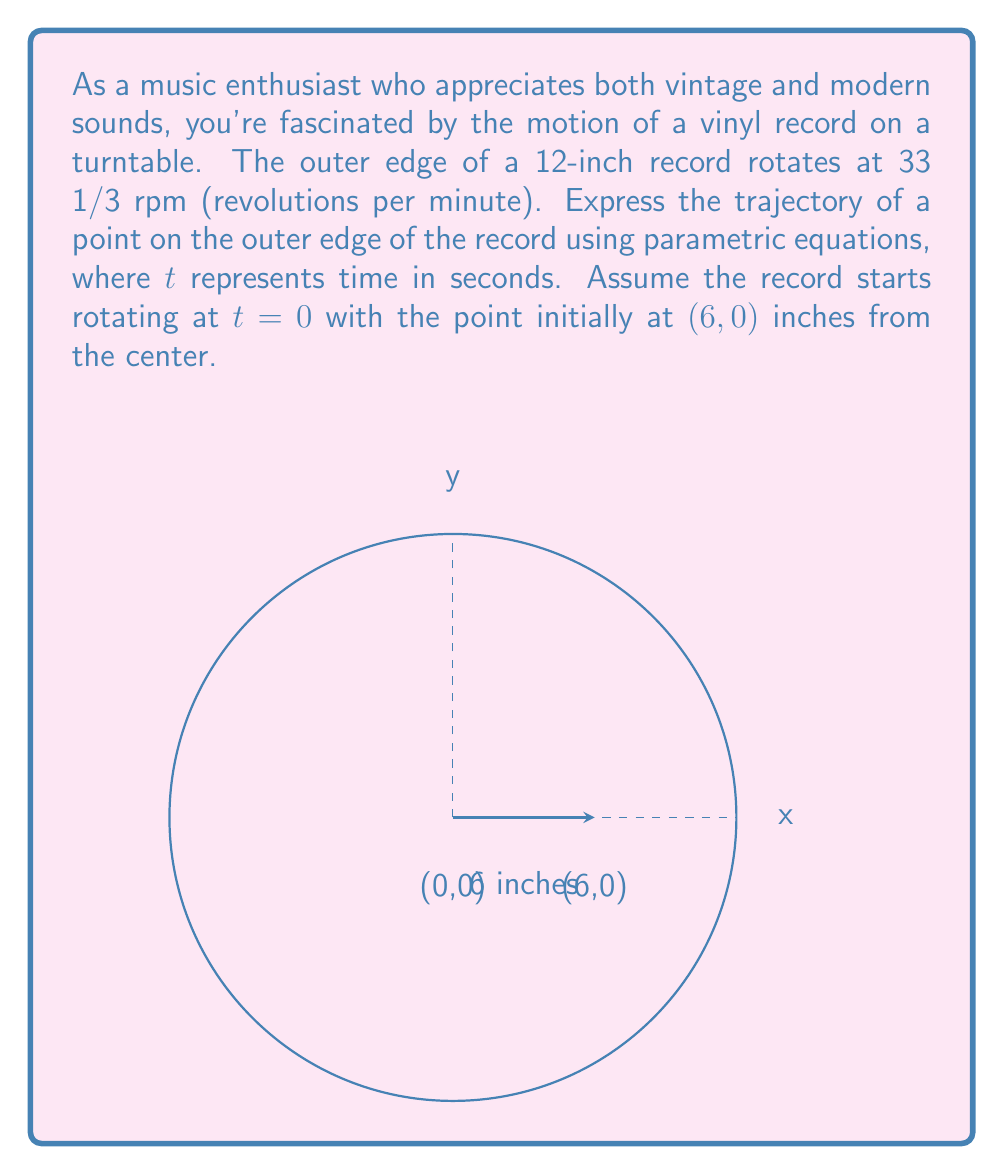Teach me how to tackle this problem. Let's approach this step-by-step:

1) First, we need to convert the rotation speed to radians per second:
   $$\omega = 33\frac{1}{3} \cdot \frac{2\pi}{60} = \frac{2\pi}{1.8} \approx 3.49 \text{ rad/s}$$

2) The general parametric equations for circular motion are:
   $$x = r\cos(\omega t)$$
   $$y = r\sin(\omega t)$$
   where $r$ is the radius and $\omega$ is the angular velocity in radians per second.

3) In this case, $r = 6$ inches (radius of a 12-inch record).

4) Substituting these values:
   $$x = 6\cos(\frac{2\pi}{1.8}t)$$
   $$y = 6\sin(\frac{2\pi}{1.8}t)$$

5) These equations describe the position $(x,y)$ of the point on the edge of the record at any time $t$ in seconds.

6) Note that at $t=0$, $x = 6$ and $y = 0$, which matches our initial condition.
Answer: $$x = 6\cos(\frac{2\pi}{1.8}t), \quad y = 6\sin(\frac{2\pi}{1.8}t)$$ 